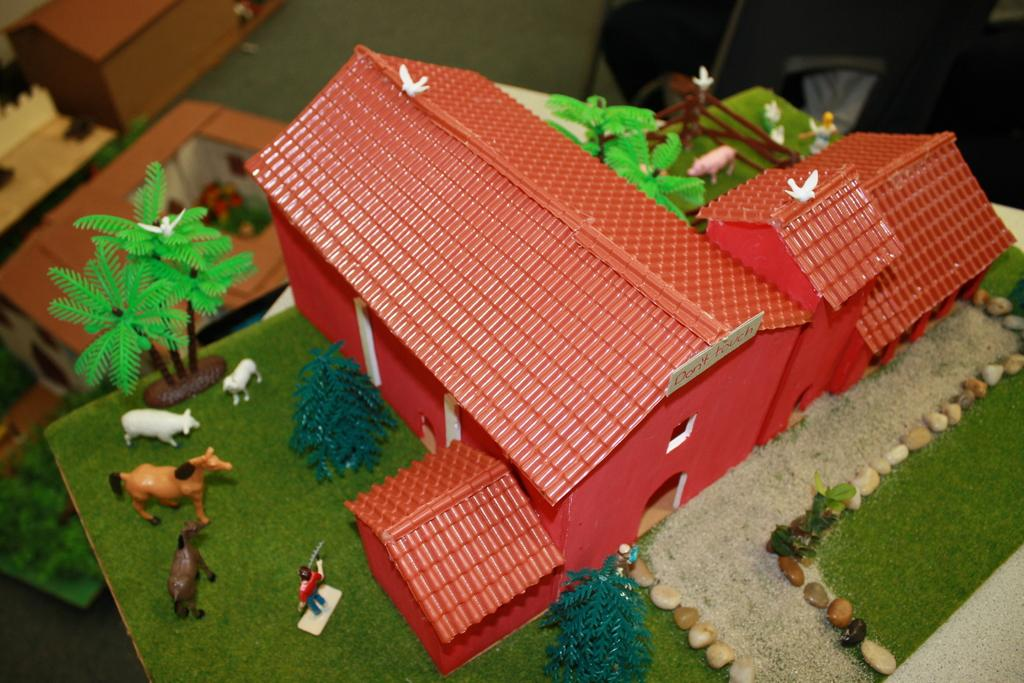What type of objects are depicted as miniatures in the image? There are miniatures of buildings and animals in the image. What is the color of the trees in the image? The trees in the image have green color. What is the color of the birds in the image? The birds in the image have white color. How many quarters are visible in the image? There are no quarters present in the image. What type of bird is missing from the image? There is no specific bird mentioned as missing from the image. 